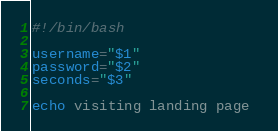<code> <loc_0><loc_0><loc_500><loc_500><_Bash_>#!/bin/bash

username="$1"
password="$2"
seconds="$3"

echo visiting landing page </code> 